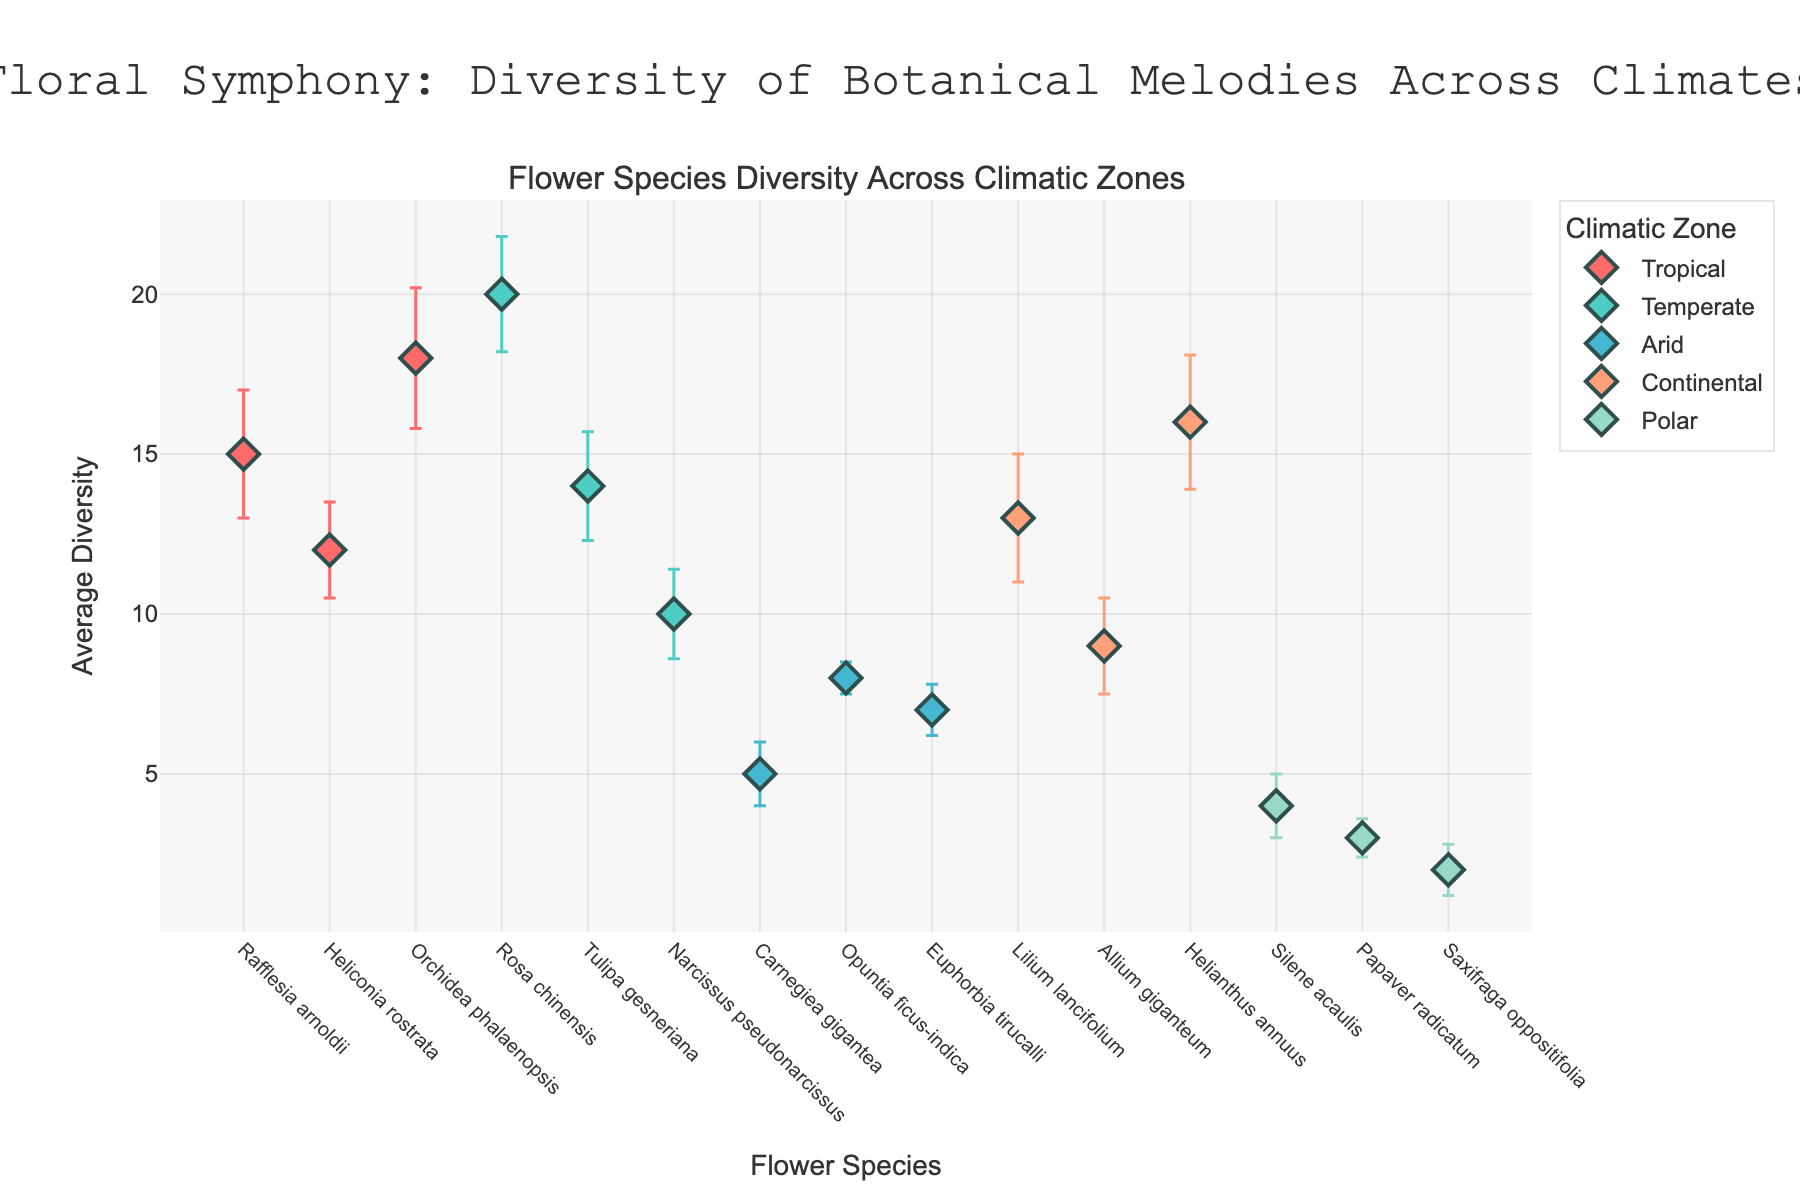Which climatic zone has the most diverse flower species as indicated by the highest average diversity value? Look for the highest average diversity value across all data points and identify the corresponding climatic zone.
Answer: Temperate Which flower species in the Tropical zone has the highest average diversity? Among the flower species in the Tropical zone, compare their average diversity values and find the highest one.
Answer: Orchidea phalaenopsis What is the title of the plot? Locate the title displayed at the top of the plot.
Answer: Floral Symphony: Diversity of Botanical Melodies Across Climates How many flower species are represented in the Arid climatic zone? Count the number of unique flower species in the Arid climatic zone.
Answer: 3 What is the range of average diversity values for the flower species in the Temperate climatic zone? Identify the minimum and maximum average diversity values for the flower species in the Temperate zone and calculate the difference.
Answer: 10 to 20 Which flower species has the highest seasonal variation in average diversity? Find the flower species with the highest error bar value indicating seasonal variation.
Answer: Orchidea phalaenopsis How do the average diversity values of "Opuntia ficus-indica" and "Helianthus annuus" compare? Identify the average diversity values for "Opuntia ficus-indica" in the Arid zone and "Helianthus annuus" in the Continental zone and compare them.
Answer: Helianthus annuus has higher diversity Among all flower species, which one in the Polar climatic zone has the lowest average diversity? Compare the average diversity values of flower species in the Polar zone and identify the lowest one.
Answer: Saxifraga oppositifolia What is the total average diversity of flower species in the Continental climatic zone? Sum the average diversity values for all flower species in the Continental zone.
Answer: 38 Considering the error bars, which climatic zone shows the highest seasonal variation in floral diversity on average? Calculate the average of the seasonal variation error bars for each climatic zone and determine the highest one.
Answer: Continental 